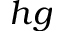Convert formula to latex. <formula><loc_0><loc_0><loc_500><loc_500>h g</formula> 